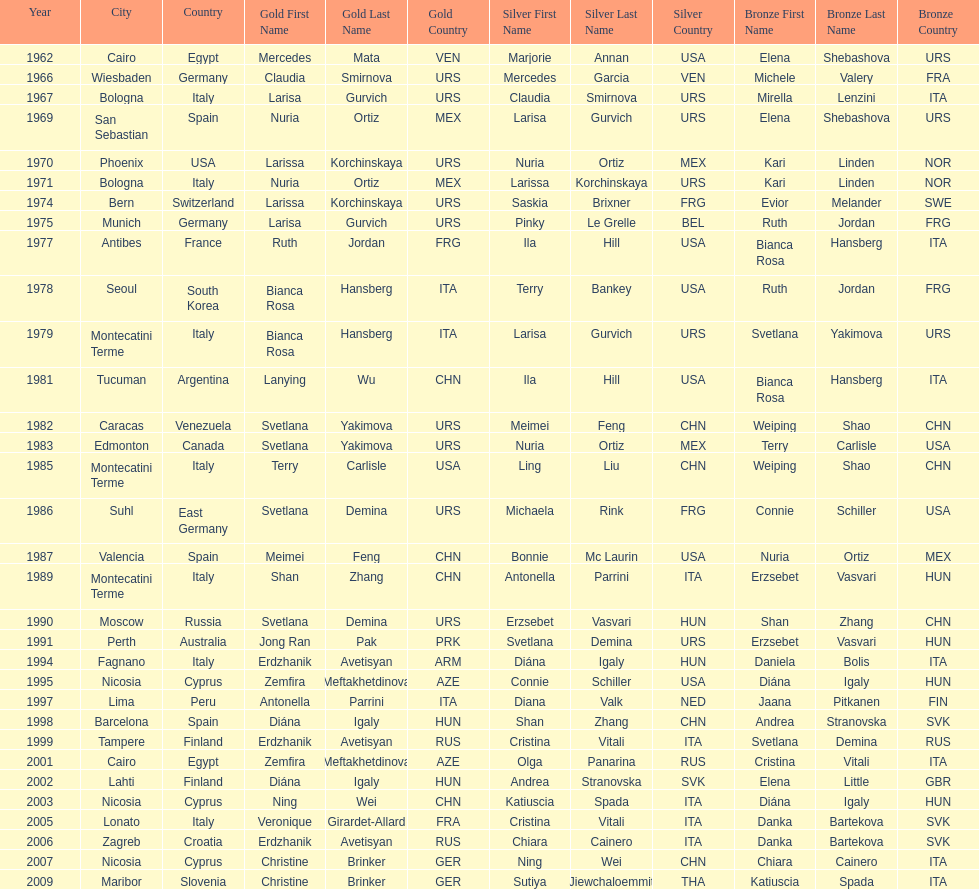Which country has won more gold medals: china or mexico? China. 